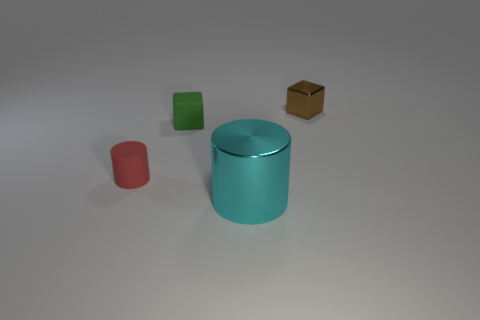Aside from the objects, what else can you notice about the setting? The setting seems quite minimalistic; there's a soft light creating gentle shadows on the floor, which indicates indoor lighting conditions. The floor itself appears smooth and is a neutral grey color, providing a nondescript background that keeps our focus on the objects. 